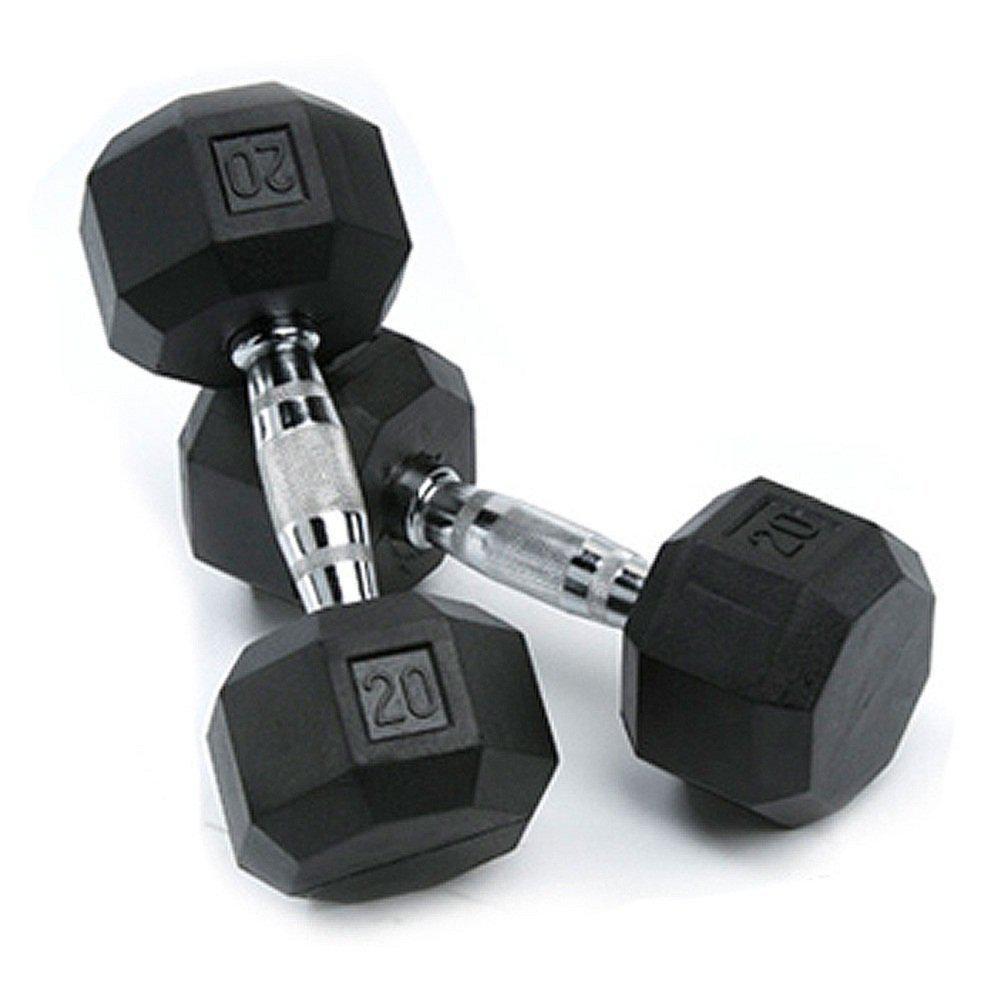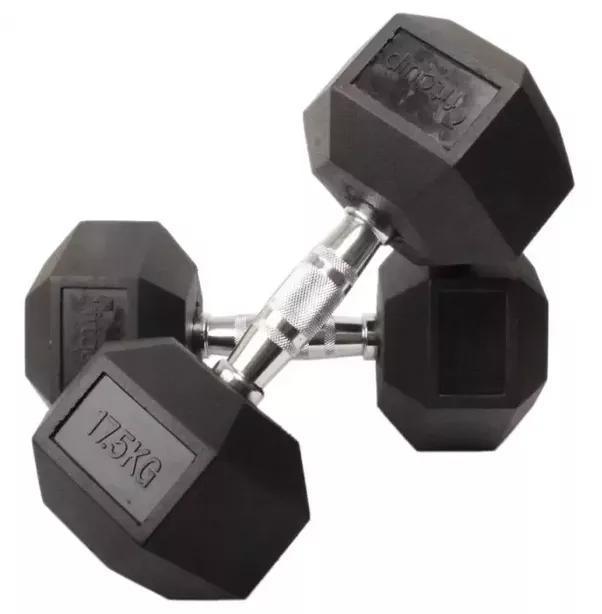The first image is the image on the left, the second image is the image on the right. Considering the images on both sides, is "The left and right image contains the same number of dumbells." valid? Answer yes or no. Yes. 